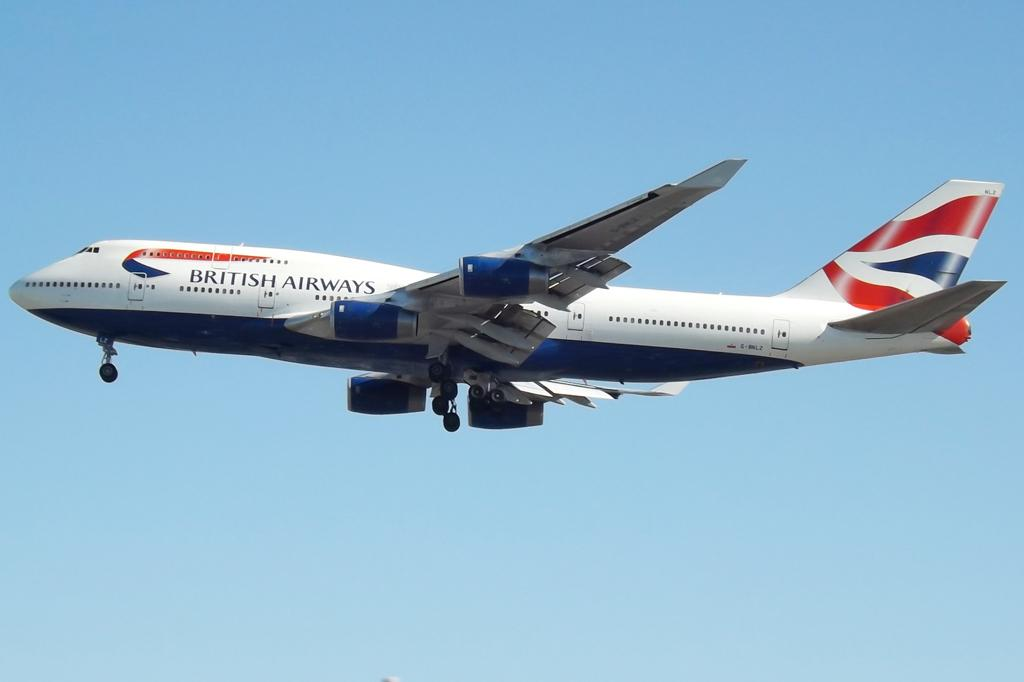<image>
Relay a brief, clear account of the picture shown. An airplane from British Airways in the sky with it 